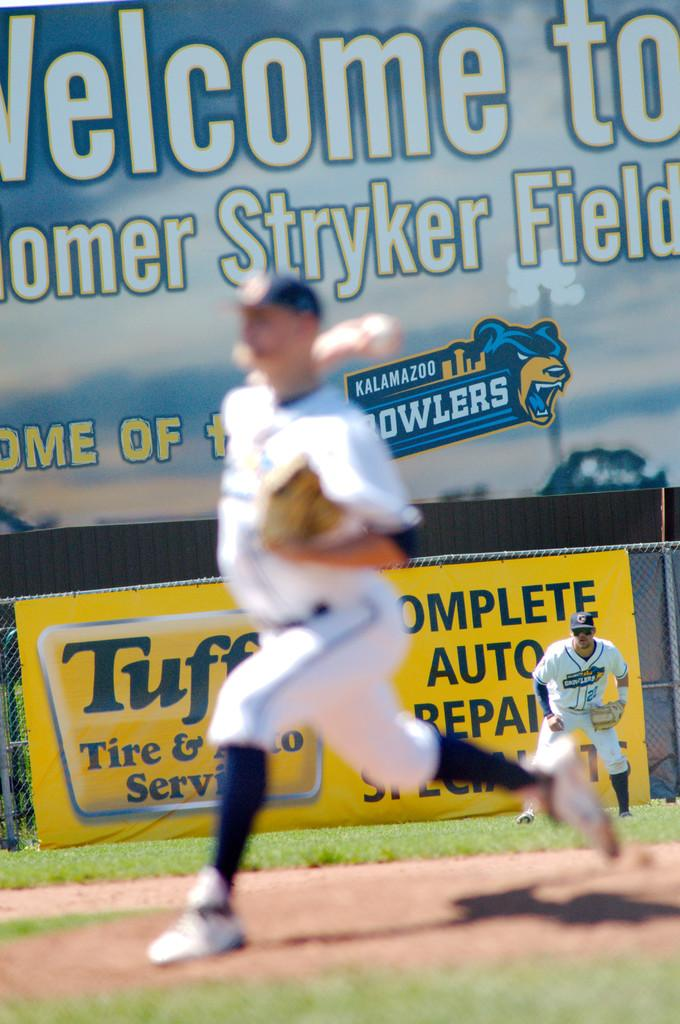Provide a one-sentence caption for the provided image. A pitcher is seen in front of an advertisement for complete auto repair. 